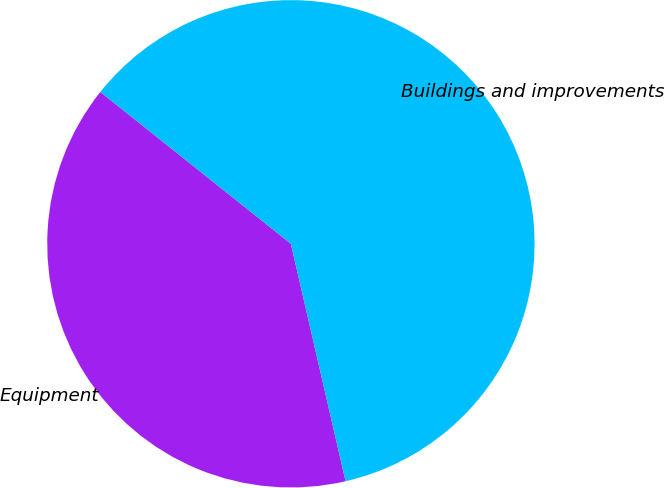<chart> <loc_0><loc_0><loc_500><loc_500><pie_chart><fcel>Equipment<fcel>Buildings and improvements<nl><fcel>39.31%<fcel>60.69%<nl></chart> 